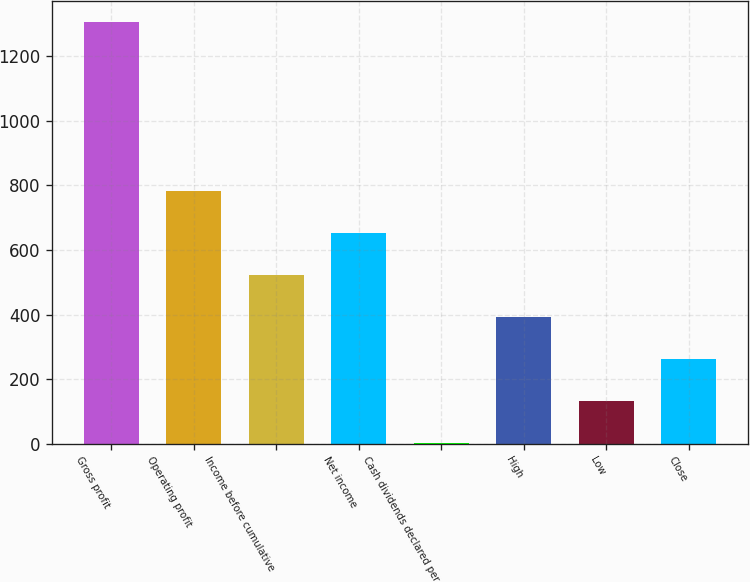Convert chart. <chart><loc_0><loc_0><loc_500><loc_500><bar_chart><fcel>Gross profit<fcel>Operating profit<fcel>Income before cumulative<fcel>Net income<fcel>Cash dividends declared per<fcel>High<fcel>Low<fcel>Close<nl><fcel>1306.6<fcel>784.12<fcel>522.89<fcel>653.5<fcel>0.45<fcel>392.28<fcel>131.06<fcel>261.67<nl></chart> 